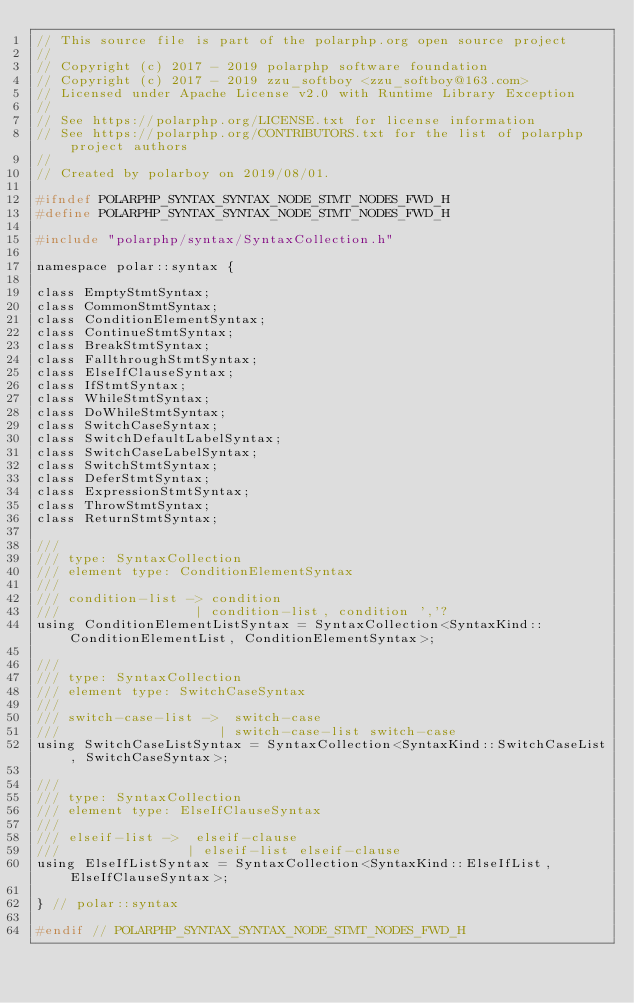Convert code to text. <code><loc_0><loc_0><loc_500><loc_500><_C_>// This source file is part of the polarphp.org open source project
//
// Copyright (c) 2017 - 2019 polarphp software foundation
// Copyright (c) 2017 - 2019 zzu_softboy <zzu_softboy@163.com>
// Licensed under Apache License v2.0 with Runtime Library Exception
//
// See https://polarphp.org/LICENSE.txt for license information
// See https://polarphp.org/CONTRIBUTORS.txt for the list of polarphp project authors
//
// Created by polarboy on 2019/08/01.

#ifndef POLARPHP_SYNTAX_SYNTAX_NODE_STMT_NODES_FWD_H
#define POLARPHP_SYNTAX_SYNTAX_NODE_STMT_NODES_FWD_H

#include "polarphp/syntax/SyntaxCollection.h"

namespace polar::syntax {

class EmptyStmtSyntax;
class CommonStmtSyntax;
class ConditionElementSyntax;
class ContinueStmtSyntax;
class BreakStmtSyntax;
class FallthroughStmtSyntax;
class ElseIfClauseSyntax;
class IfStmtSyntax;
class WhileStmtSyntax;
class DoWhileStmtSyntax;
class SwitchCaseSyntax;
class SwitchDefaultLabelSyntax;
class SwitchCaseLabelSyntax;
class SwitchStmtSyntax;
class DeferStmtSyntax;
class ExpressionStmtSyntax;
class ThrowStmtSyntax;
class ReturnStmtSyntax;

///
/// type: SyntaxCollection
/// element type: ConditionElementSyntax
///
/// condition-list -> condition
///                 | condition-list, condition ','?
using ConditionElementListSyntax = SyntaxCollection<SyntaxKind::ConditionElementList, ConditionElementSyntax>;

///
/// type: SyntaxCollection
/// element type: SwitchCaseSyntax
///
/// switch-case-list ->  switch-case
///                    | switch-case-list switch-case
using SwitchCaseListSyntax = SyntaxCollection<SyntaxKind::SwitchCaseList, SwitchCaseSyntax>;

///
/// type: SyntaxCollection
/// element type: ElseIfClauseSyntax
///
/// elseif-list ->  elseif-clause
///                | elseif-list elseif-clause
using ElseIfListSyntax = SyntaxCollection<SyntaxKind::ElseIfList, ElseIfClauseSyntax>;

} // polar::syntax

#endif // POLARPHP_SYNTAX_SYNTAX_NODE_STMT_NODES_FWD_H
</code> 